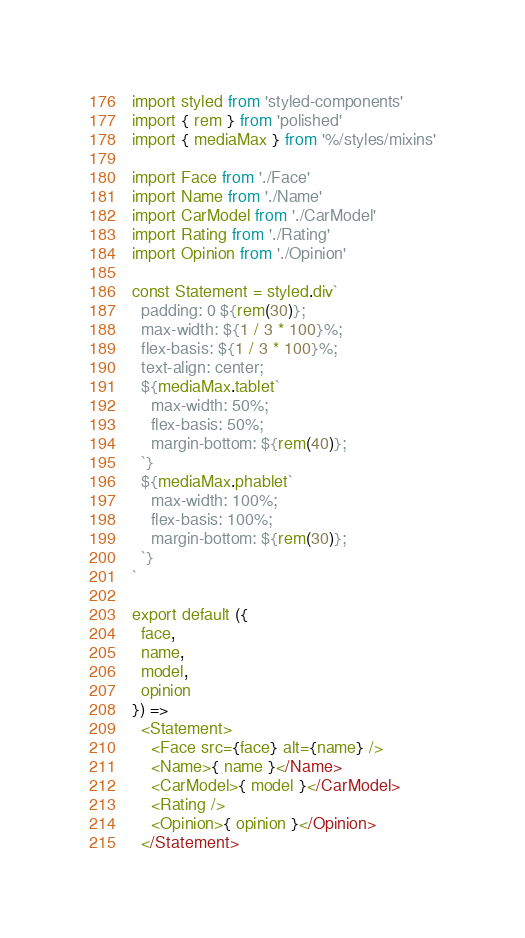<code> <loc_0><loc_0><loc_500><loc_500><_JavaScript_>import styled from 'styled-components'
import { rem } from 'polished'
import { mediaMax } from '%/styles/mixins'

import Face from './Face'
import Name from './Name'
import CarModel from './CarModel'
import Rating from './Rating'
import Opinion from './Opinion'

const Statement = styled.div`
  padding: 0 ${rem(30)};
  max-width: ${1 / 3 * 100}%;
  flex-basis: ${1 / 3 * 100}%;
  text-align: center;
  ${mediaMax.tablet`
    max-width: 50%;
    flex-basis: 50%;
    margin-bottom: ${rem(40)};
  `}
  ${mediaMax.phablet`
    max-width: 100%;
    flex-basis: 100%;
    margin-bottom: ${rem(30)};
  `}
`

export default ({
  face,
  name,
  model,
  opinion
}) =>
  <Statement>
    <Face src={face} alt={name} />
    <Name>{ name }</Name>
    <CarModel>{ model }</CarModel>
    <Rating />
    <Opinion>{ opinion }</Opinion>
  </Statement>
</code> 